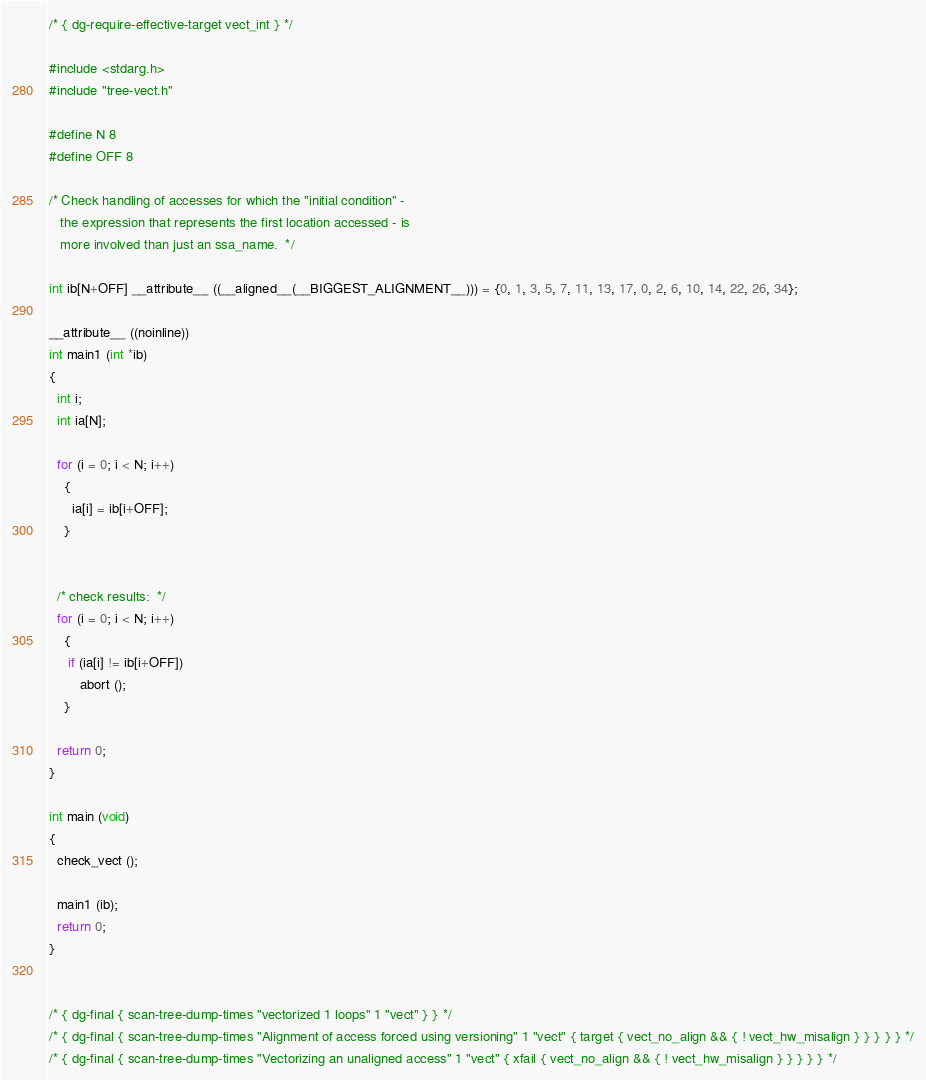Convert code to text. <code><loc_0><loc_0><loc_500><loc_500><_C_>/* { dg-require-effective-target vect_int } */

#include <stdarg.h>
#include "tree-vect.h"

#define N 8
#define OFF 8

/* Check handling of accesses for which the "initial condition" -
   the expression that represents the first location accessed - is
   more involved than just an ssa_name.  */

int ib[N+OFF] __attribute__ ((__aligned__(__BIGGEST_ALIGNMENT__))) = {0, 1, 3, 5, 7, 11, 13, 17, 0, 2, 6, 10, 14, 22, 26, 34};

__attribute__ ((noinline))
int main1 (int *ib)
{
  int i;
  int ia[N];

  for (i = 0; i < N; i++)
    {
      ia[i] = ib[i+OFF];
    }


  /* check results:  */
  for (i = 0; i < N; i++)
    {
     if (ia[i] != ib[i+OFF])
        abort ();
    }

  return 0;
}

int main (void)
{
  check_vect ();

  main1 (ib);
  return 0;
}


/* { dg-final { scan-tree-dump-times "vectorized 1 loops" 1 "vect" } } */
/* { dg-final { scan-tree-dump-times "Alignment of access forced using versioning" 1 "vect" { target { vect_no_align && { ! vect_hw_misalign } } } } } */
/* { dg-final { scan-tree-dump-times "Vectorizing an unaligned access" 1 "vect" { xfail { vect_no_align && { ! vect_hw_misalign } } } } } */
</code> 